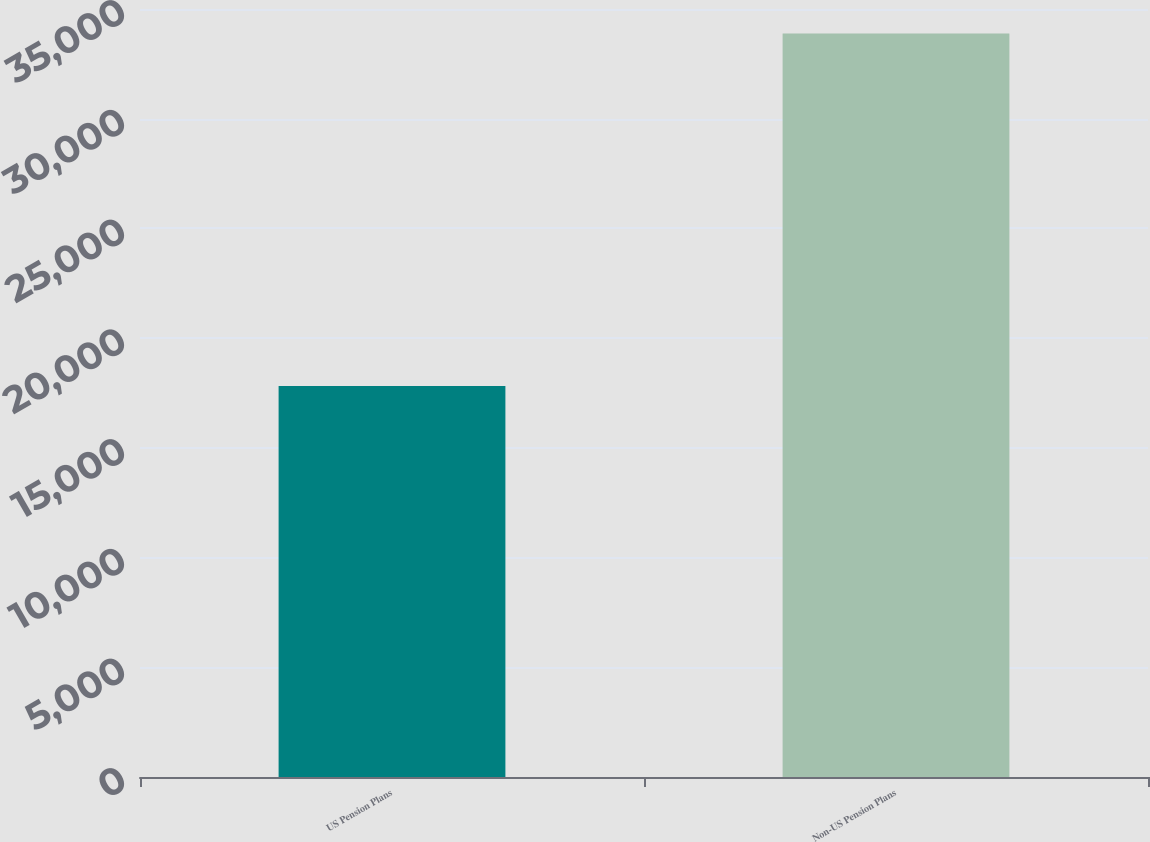<chart> <loc_0><loc_0><loc_500><loc_500><bar_chart><fcel>US Pension Plans<fcel>Non-US Pension Plans<nl><fcel>17816<fcel>33889<nl></chart> 